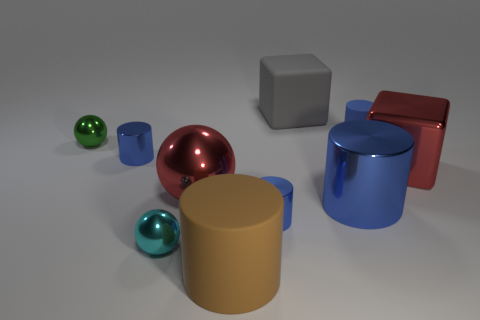What color is the tiny shiny thing that is both in front of the big sphere and behind the tiny cyan metal thing?
Your answer should be very brief. Blue. What shape is the large rubber object behind the big matte cylinder?
Your answer should be very brief. Cube. What size is the red thing that is right of the small metal object on the right side of the large rubber thing left of the matte block?
Provide a succinct answer. Large. There is a red block that is to the right of the cyan shiny sphere; how many metallic objects are in front of it?
Make the answer very short. 4. There is a blue cylinder that is both right of the big gray object and in front of the green metallic ball; how big is it?
Your answer should be very brief. Large. How many shiny things are either cyan objects or green balls?
Provide a succinct answer. 2. What is the big brown cylinder made of?
Provide a short and direct response. Rubber. What is the material of the cylinder in front of the tiny sphere to the right of the tiny green thing that is behind the small cyan metallic thing?
Offer a terse response. Rubber. There is a green thing that is the same size as the blue matte object; what is its shape?
Offer a very short reply. Sphere. How many objects are either green metal spheres or blue things behind the tiny green thing?
Offer a terse response. 2. 